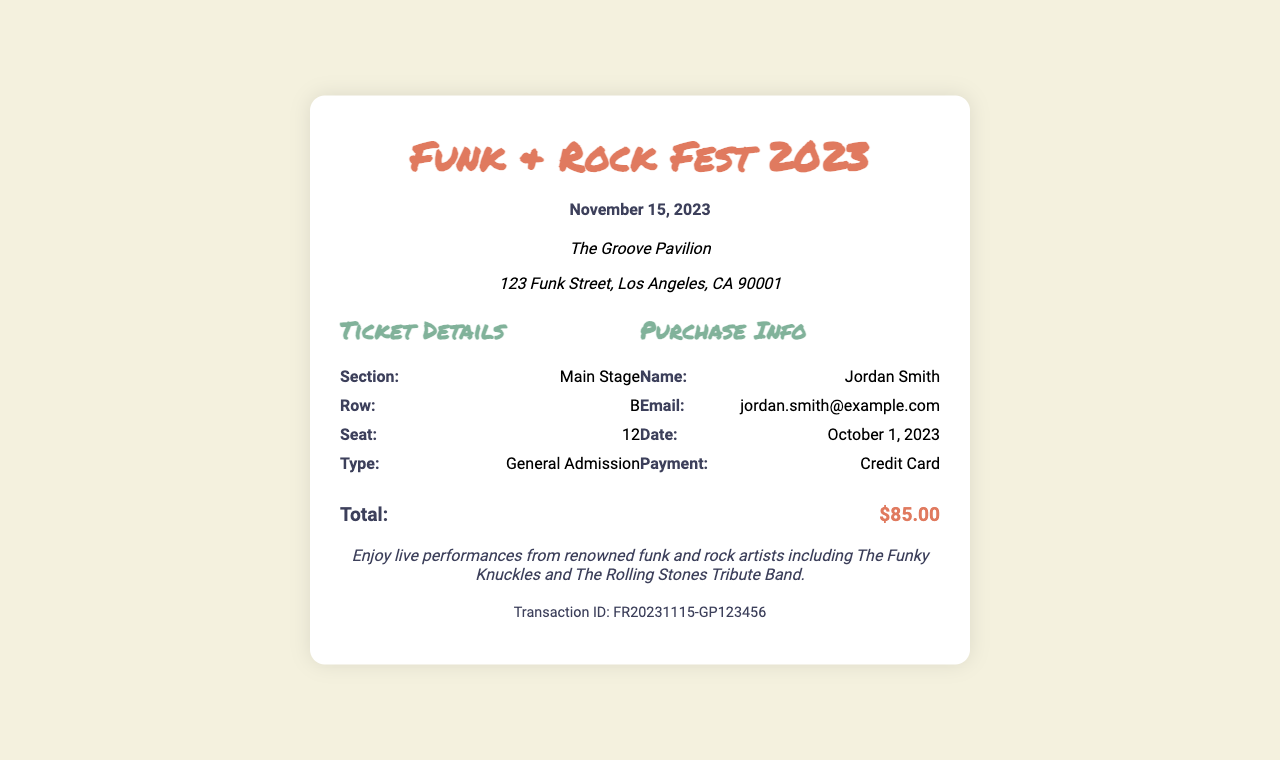What is the date of the festival? The date of the festival is specified in the header of the receipt as November 15, 2023.
Answer: November 15, 2023 What is the name of the venue? The name of the venue is mentioned below the header and is "The Groove Pavilion."
Answer: The Groove Pavilion What is the seat number for this ticket? The seat number is detailed in the ticket information section as 12.
Answer: 12 Who is the purchaser's name? The purchaser's name is stated in the purchase info section as Jordan Smith.
Answer: Jordan Smith What is the total cost of the ticket? The total cost is indicated near the bottom of the receipt as $85.00.
Answer: $85.00 In which row is the seat located? The row for the seat is specified in the ticket information as B.
Answer: B What type of ticket was purchased? The ticket type is mentioned as General Admission in the ticket details.
Answer: General Admission What method of payment was used? The method of payment is provided in the purchase info and states Credit Card.
Answer: Credit Card Who is performing at the festival? The additional info section lists the artists performing as The Funky Knuckles and The Rolling Stones Tribute Band.
Answer: The Funky Knuckles and The Rolling Stones Tribute Band 